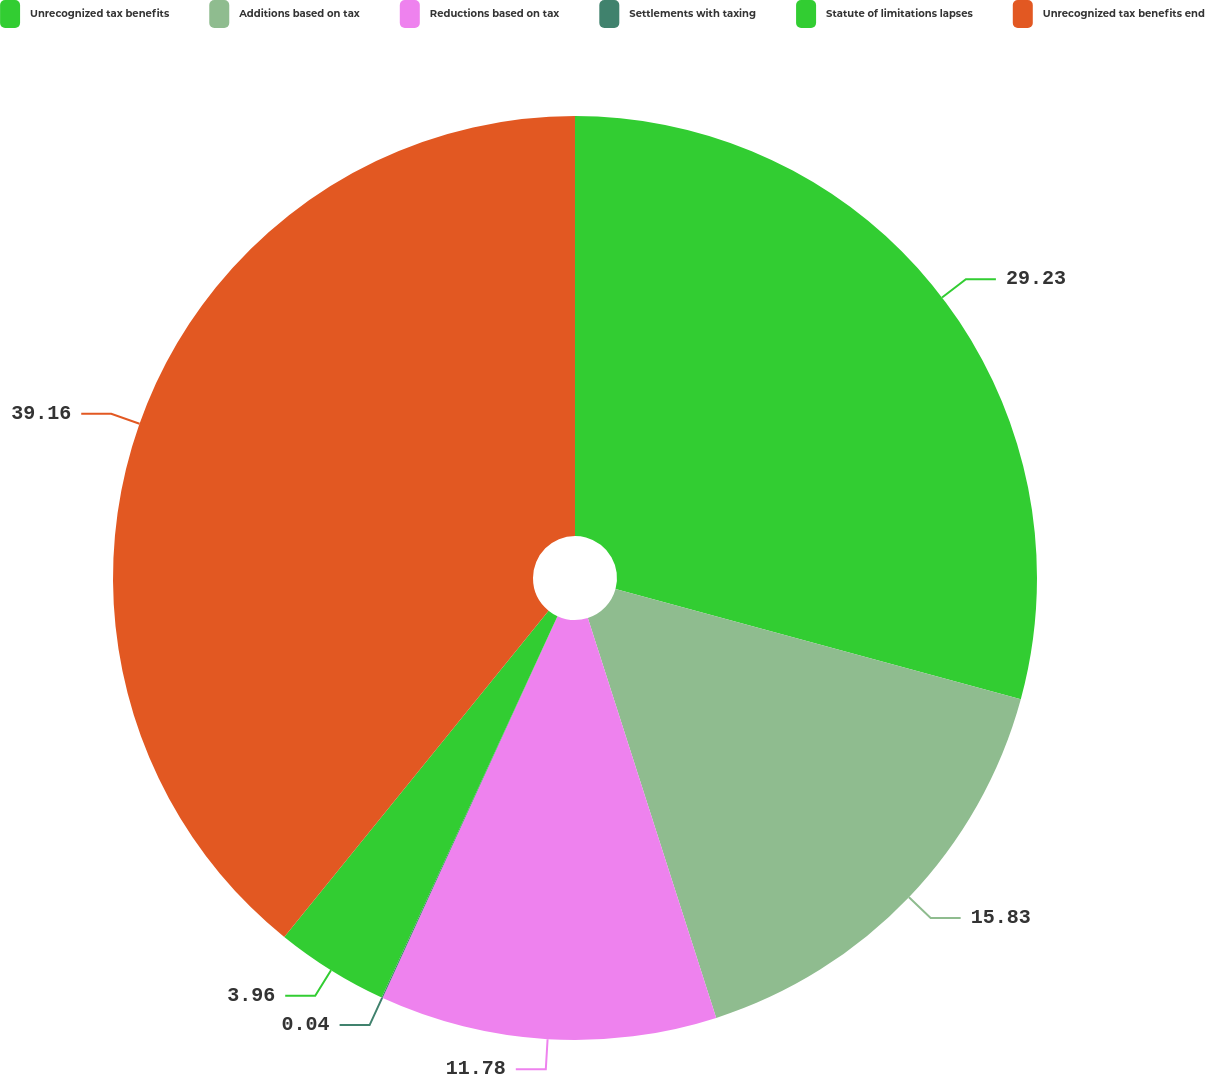<chart> <loc_0><loc_0><loc_500><loc_500><pie_chart><fcel>Unrecognized tax benefits<fcel>Additions based on tax<fcel>Reductions based on tax<fcel>Settlements with taxing<fcel>Statute of limitations lapses<fcel>Unrecognized tax benefits end<nl><fcel>29.23%<fcel>15.83%<fcel>11.78%<fcel>0.04%<fcel>3.96%<fcel>39.17%<nl></chart> 